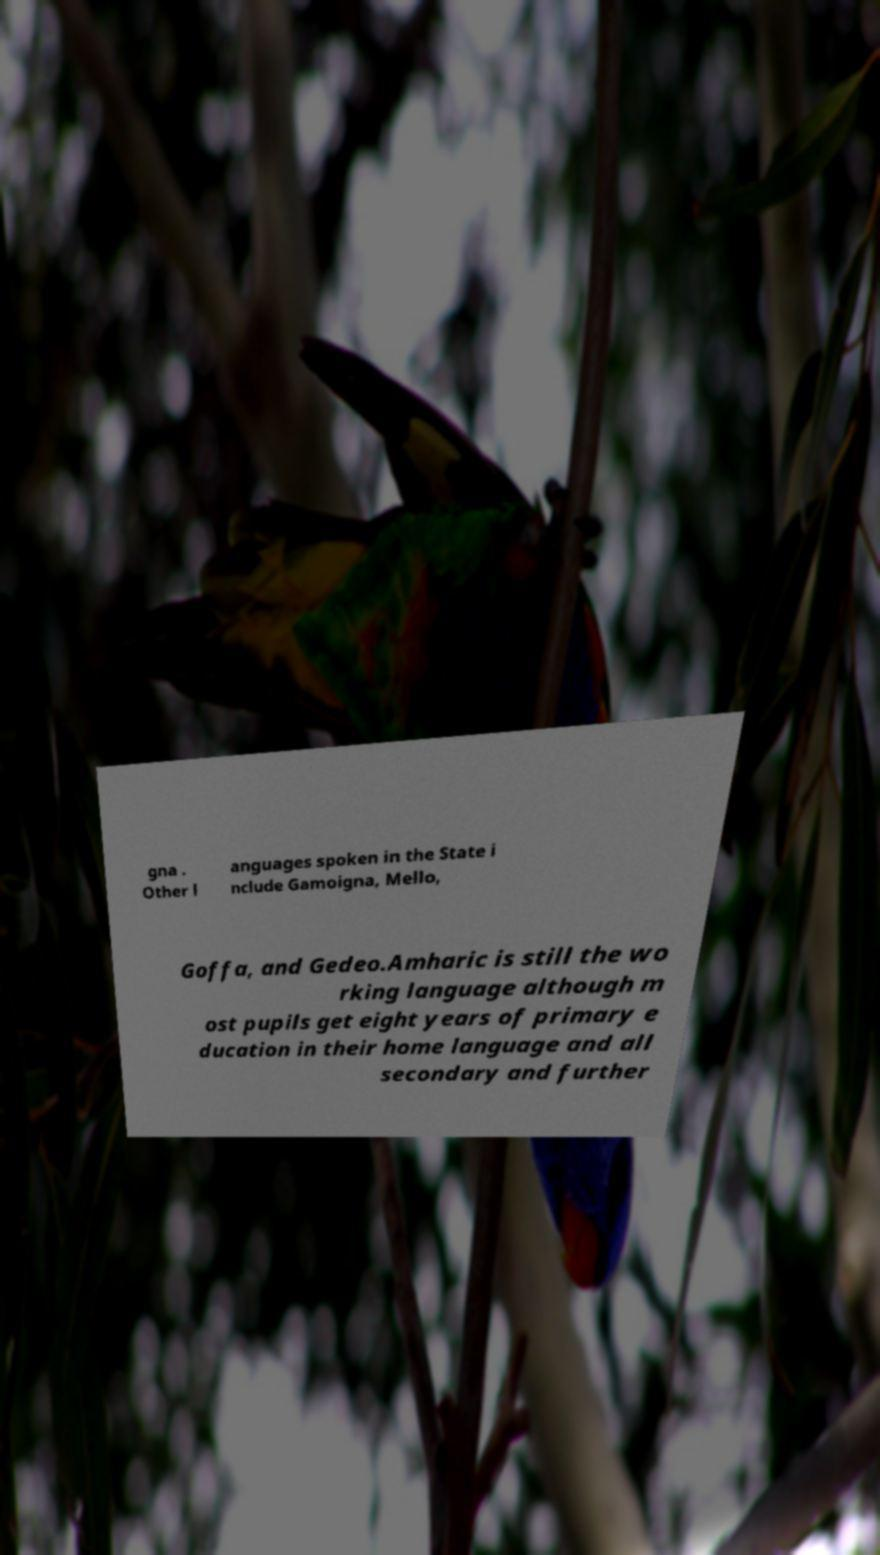Could you assist in decoding the text presented in this image and type it out clearly? gna . Other l anguages spoken in the State i nclude Gamoigna, Mello, Goffa, and Gedeo.Amharic is still the wo rking language although m ost pupils get eight years of primary e ducation in their home language and all secondary and further 